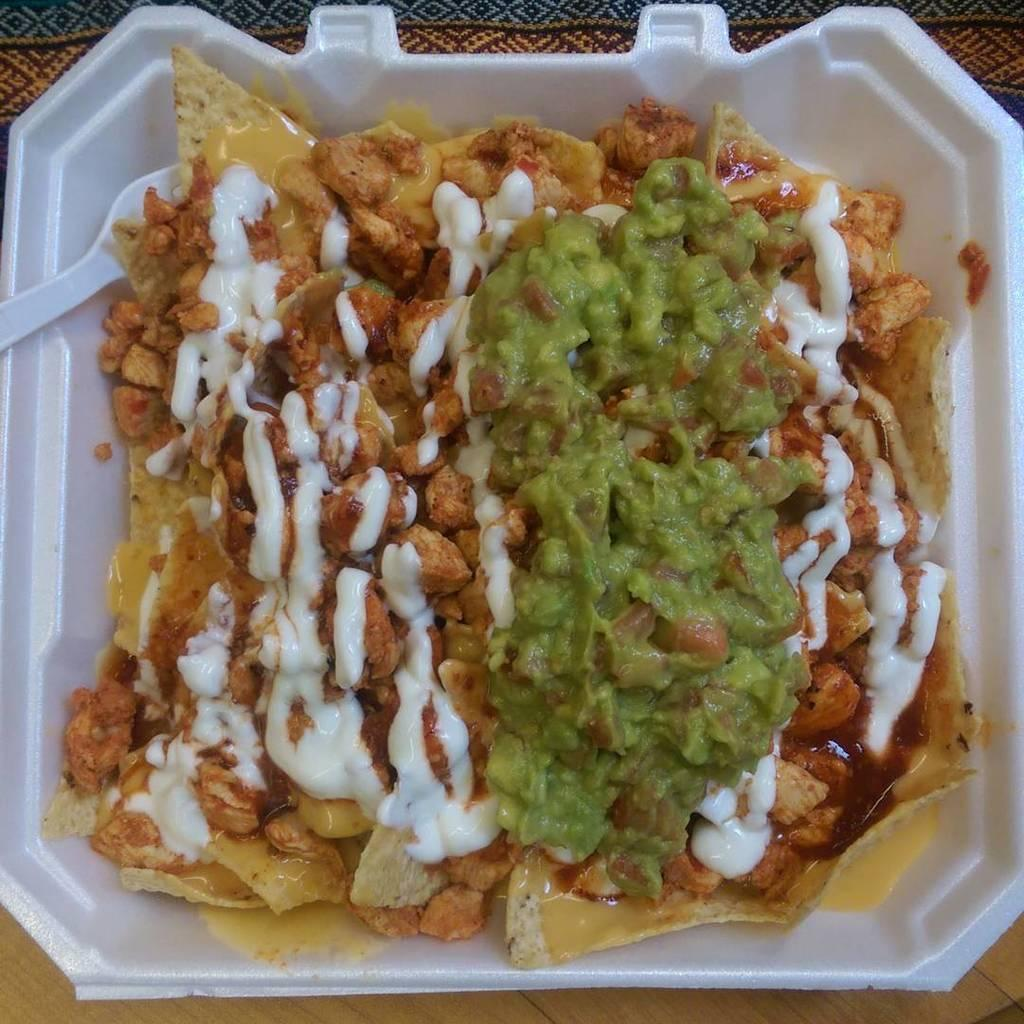What is in the bowl that is visible in the image? The bowl contains food. Can you describe the surface on which the bowl is placed? The wooden surface is present in the image. Where is the bowl located in the image? The bowl is placed on the wooden surface. What type of clam can be seen breathing honey in the image? There is no clam present in the image, and clams do not breathe honey. 